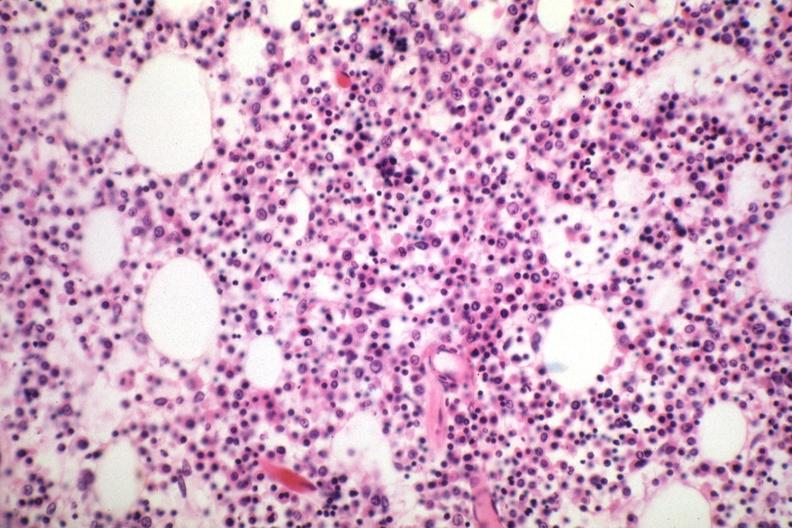what is present?
Answer the question using a single word or phrase. Hematologic 